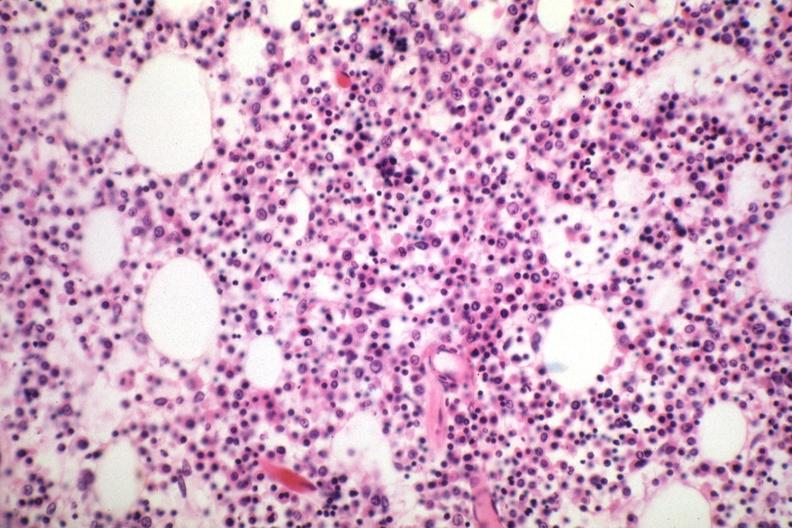what is present?
Answer the question using a single word or phrase. Hematologic 